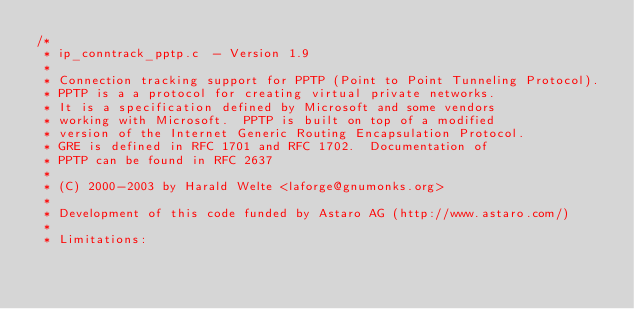Convert code to text. <code><loc_0><loc_0><loc_500><loc_500><_C_>/*
 * ip_conntrack_pptp.c	- Version 1.9
 *
 * Connection tracking support for PPTP (Point to Point Tunneling Protocol).
 * PPTP is a a protocol for creating virtual private networks.
 * It is a specification defined by Microsoft and some vendors
 * working with Microsoft.  PPTP is built on top of a modified
 * version of the Internet Generic Routing Encapsulation Protocol.
 * GRE is defined in RFC 1701 and RFC 1702.  Documentation of
 * PPTP can be found in RFC 2637
 *
 * (C) 2000-2003 by Harald Welte <laforge@gnumonks.org>
 *
 * Development of this code funded by Astaro AG (http://www.astaro.com/)
 *
 * Limitations:</code> 